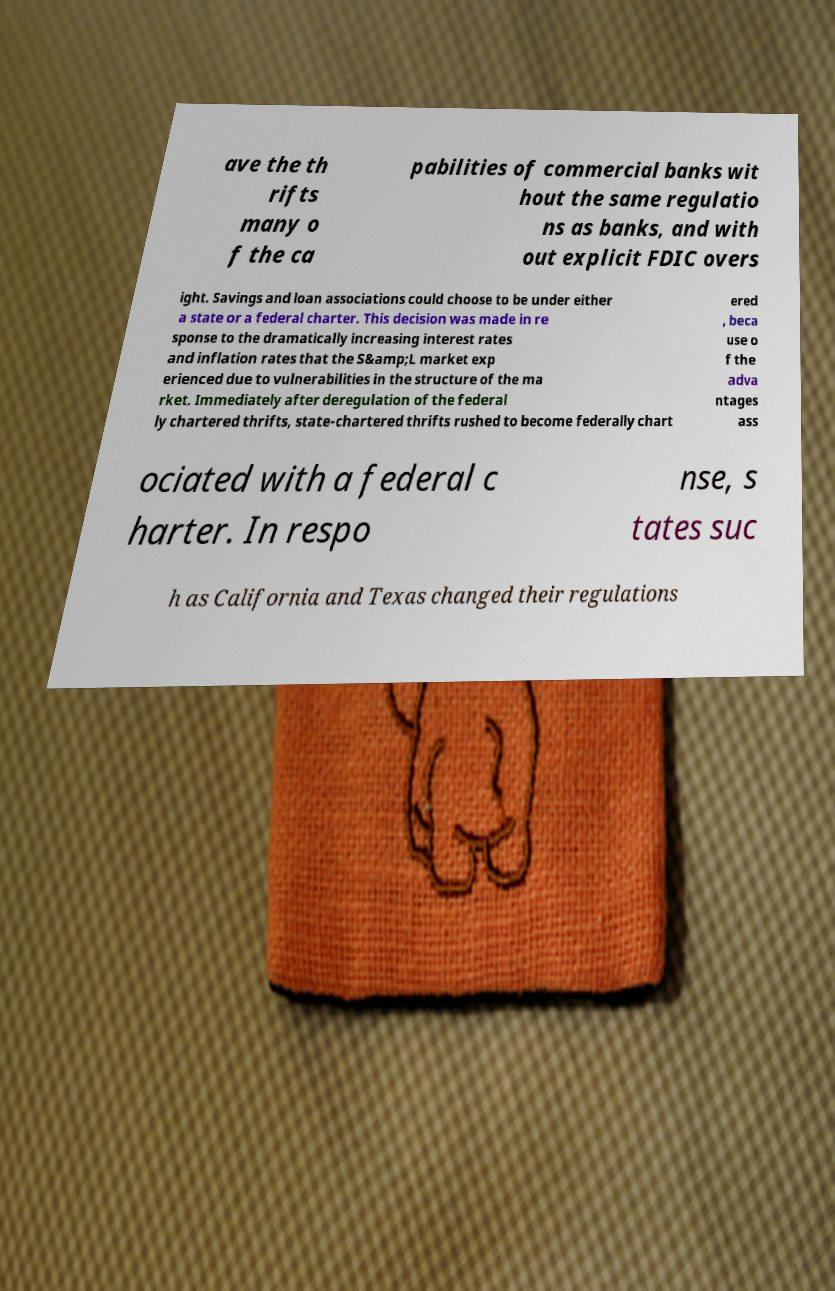Can you accurately transcribe the text from the provided image for me? ave the th rifts many o f the ca pabilities of commercial banks wit hout the same regulatio ns as banks, and with out explicit FDIC overs ight. Savings and loan associations could choose to be under either a state or a federal charter. This decision was made in re sponse to the dramatically increasing interest rates and inflation rates that the S&amp;L market exp erienced due to vulnerabilities in the structure of the ma rket. Immediately after deregulation of the federal ly chartered thrifts, state-chartered thrifts rushed to become federally chart ered , beca use o f the adva ntages ass ociated with a federal c harter. In respo nse, s tates suc h as California and Texas changed their regulations 